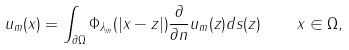Convert formula to latex. <formula><loc_0><loc_0><loc_500><loc_500>u _ { m } ( x ) = \int _ { \partial \Omega } \Phi _ { \lambda _ { m } } ( | x - z | ) \frac { \partial } { \partial n } u _ { m } ( z ) d s ( z ) \quad x \in \Omega ,</formula> 